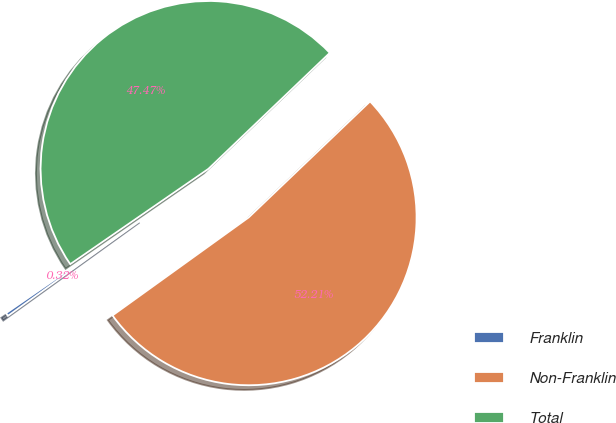Convert chart. <chart><loc_0><loc_0><loc_500><loc_500><pie_chart><fcel>Franklin<fcel>Non-Franklin<fcel>Total<nl><fcel>0.32%<fcel>52.21%<fcel>47.47%<nl></chart> 